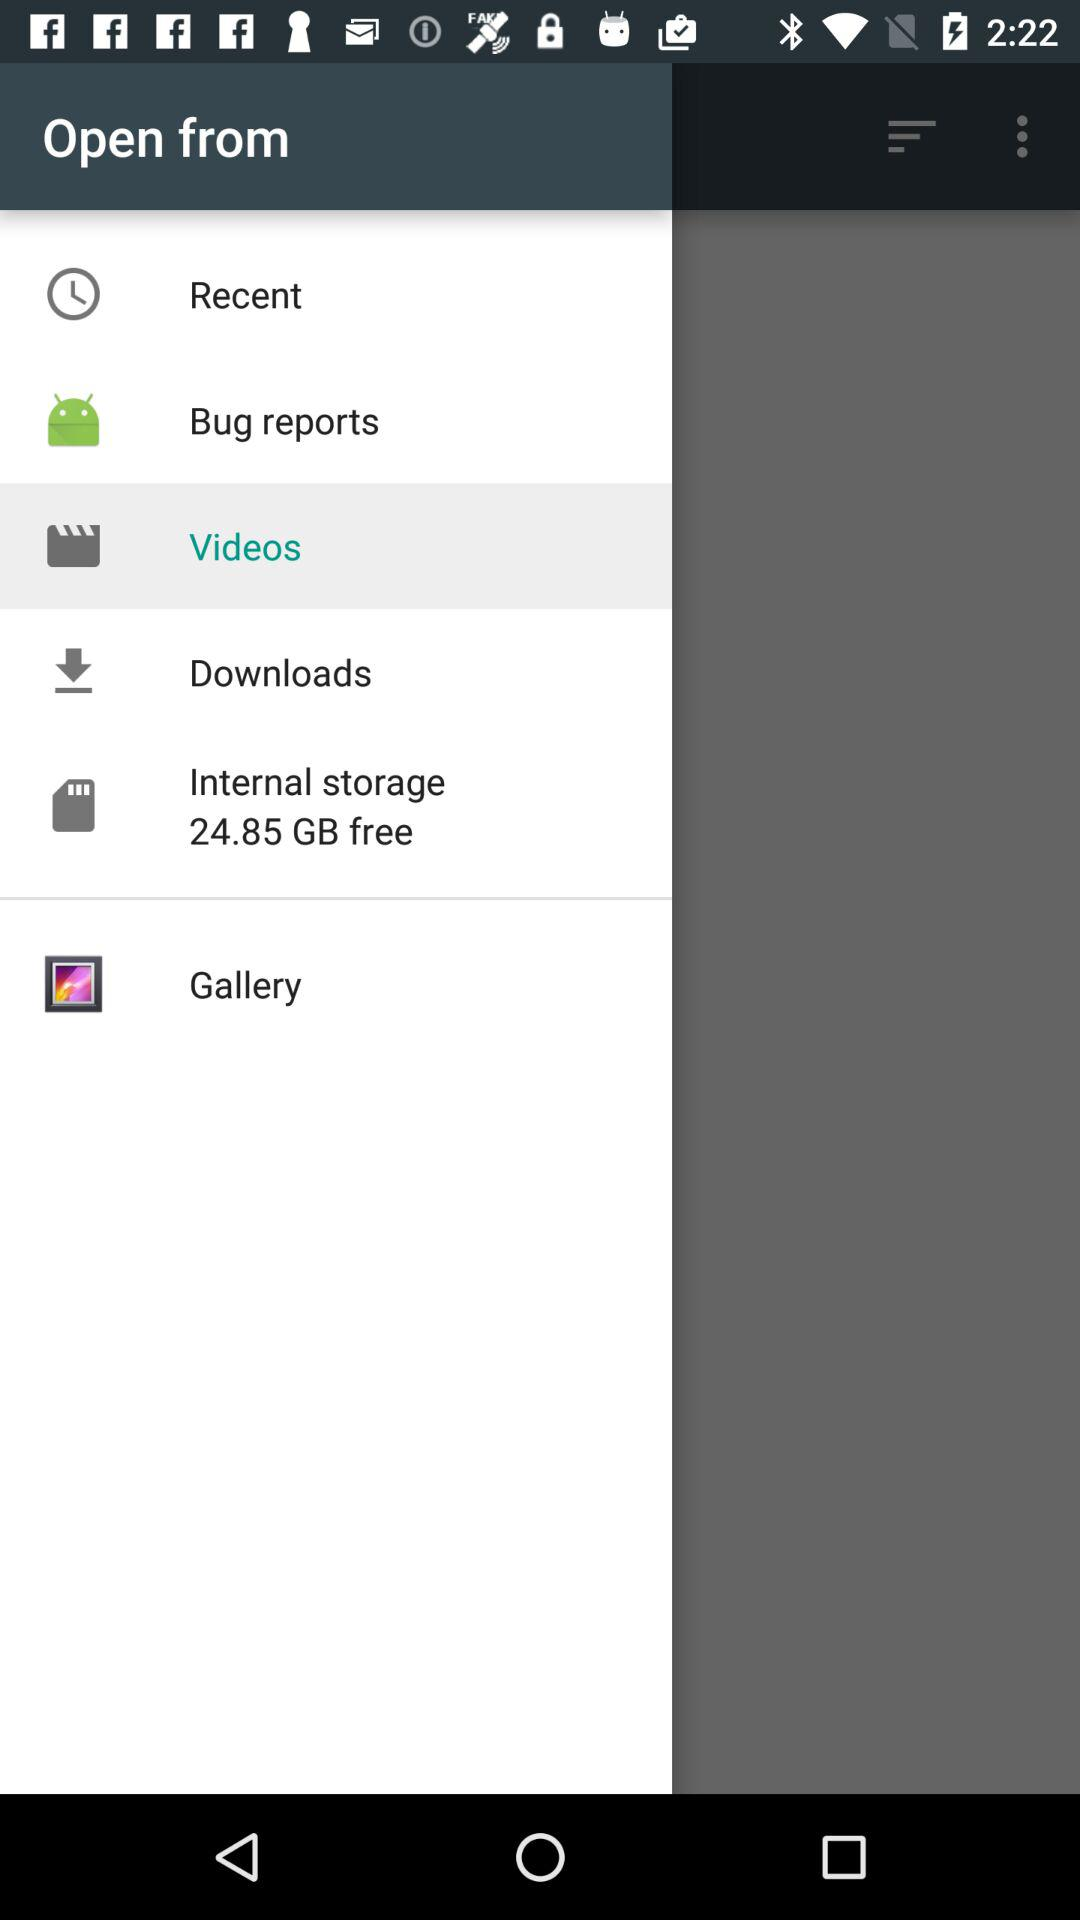What is the selected bar? The selected bar is "Videos". 